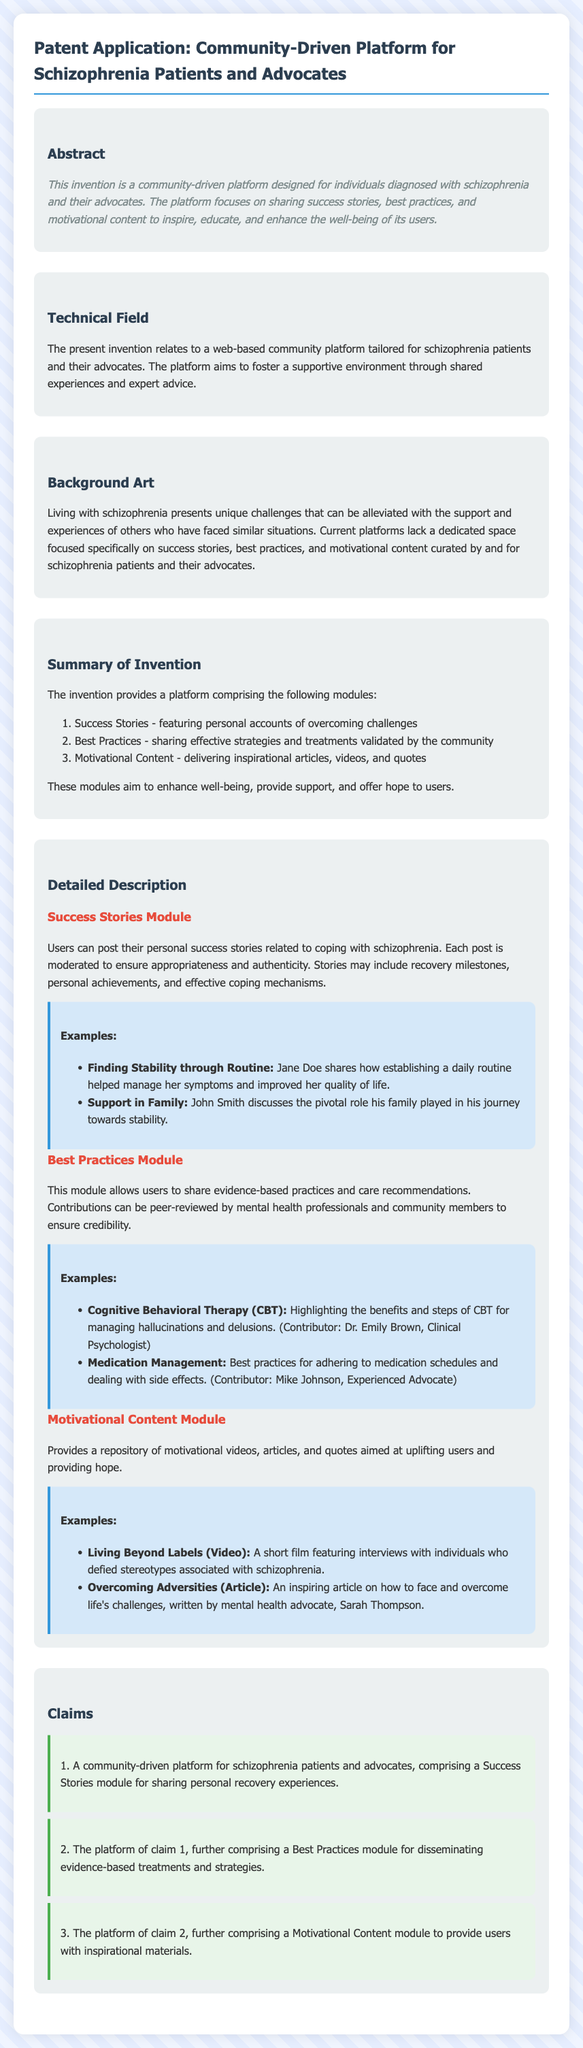What is the purpose of the platform? The platform is designed for individuals diagnosed with schizophrenia and their advocates to share success stories, best practices, and motivational content.
Answer: Sharing success stories, best practices, and motivational content What does the Success Stories module include? The Success Stories module allows users to post personal success stories related to coping with schizophrenia.
Answer: Personal success stories Who contributed to the article about Cognitive Behavioral Therapy? The contributor for the CBT article is Dr. Emily Brown, Clinical Psychologist.
Answer: Dr. Emily Brown How many modules are described in the summary of the invention? The summary outlines three main modules for the platform.
Answer: Three What is the primary audience for the platform? The platform is primarily tailored for schizophrenia patients and their advocates.
Answer: Schizophrenia patients and advocates What type of content is included in the Motivational Content module? The Motivational Content module includes motivational videos, articles, and quotes.
Answer: Videos, articles, and quotes What is the main concern addressed in the Background Art section? The main concern is that current platforms lack a dedicated space focused specifically on success stories and motivational content for schizophrenia patients.
Answer: Lack of dedicated space What is the claim number for the Best Practices module? The Best Practices module is mentioned in claim number 2.
Answer: 2 